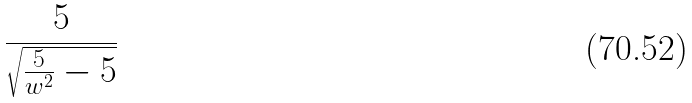Convert formula to latex. <formula><loc_0><loc_0><loc_500><loc_500>\frac { 5 } { \sqrt { \frac { 5 } { w ^ { 2 } } - 5 } }</formula> 